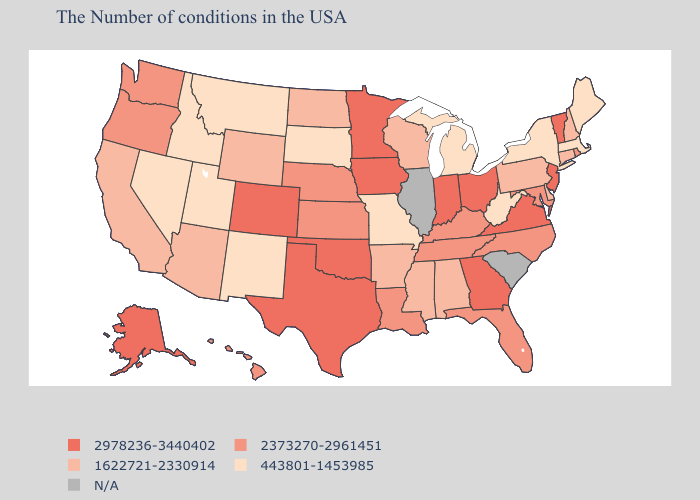Name the states that have a value in the range 443801-1453985?
Concise answer only. Maine, Massachusetts, New York, West Virginia, Michigan, Missouri, South Dakota, New Mexico, Utah, Montana, Idaho, Nevada. Name the states that have a value in the range 2978236-3440402?
Answer briefly. Vermont, New Jersey, Virginia, Ohio, Georgia, Indiana, Minnesota, Iowa, Oklahoma, Texas, Colorado, Alaska. Which states have the lowest value in the South?
Quick response, please. West Virginia. What is the highest value in the MidWest ?
Write a very short answer. 2978236-3440402. Does New Mexico have the lowest value in the West?
Concise answer only. Yes. What is the lowest value in states that border Utah?
Answer briefly. 443801-1453985. Does West Virginia have the lowest value in the South?
Keep it brief. Yes. Name the states that have a value in the range 1622721-2330914?
Answer briefly. New Hampshire, Connecticut, Delaware, Pennsylvania, Alabama, Wisconsin, Mississippi, Arkansas, North Dakota, Wyoming, Arizona, California. Name the states that have a value in the range 443801-1453985?
Give a very brief answer. Maine, Massachusetts, New York, West Virginia, Michigan, Missouri, South Dakota, New Mexico, Utah, Montana, Idaho, Nevada. What is the value of Louisiana?
Quick response, please. 2373270-2961451. What is the lowest value in the USA?
Give a very brief answer. 443801-1453985. What is the value of Virginia?
Be succinct. 2978236-3440402. Which states have the lowest value in the USA?
Give a very brief answer. Maine, Massachusetts, New York, West Virginia, Michigan, Missouri, South Dakota, New Mexico, Utah, Montana, Idaho, Nevada. 